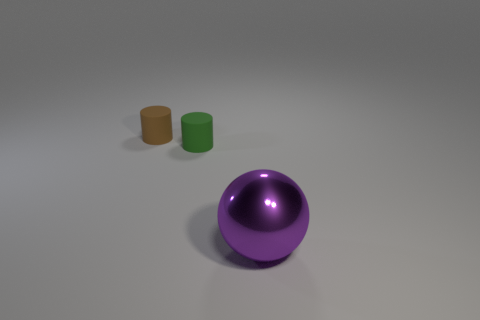How many other things are the same color as the big shiny ball?
Offer a terse response. 0. The other tiny thing that is the same shape as the tiny brown thing is what color?
Offer a very short reply. Green. Is there anything else that has the same shape as the large thing?
Your answer should be very brief. No. How many cylinders are small brown rubber things or tiny blue things?
Make the answer very short. 1. What is the shape of the tiny brown rubber object?
Offer a very short reply. Cylinder. There is a small brown thing; are there any tiny green cylinders on the right side of it?
Keep it short and to the point. Yes. Is the green object made of the same material as the big purple thing in front of the small brown matte cylinder?
Offer a terse response. No. There is a large purple shiny object that is in front of the small green cylinder; is it the same shape as the brown thing?
Your response must be concise. No. How many other purple things have the same material as the big object?
Your answer should be very brief. 0. How many objects are tiny cylinders to the left of the tiny green cylinder or matte cylinders?
Provide a succinct answer. 2. 